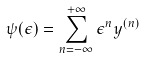<formula> <loc_0><loc_0><loc_500><loc_500>\psi ( \epsilon ) = \sum _ { n = - \infty } ^ { + \infty } { \epsilon } ^ { n } y ^ { ( n ) }</formula> 